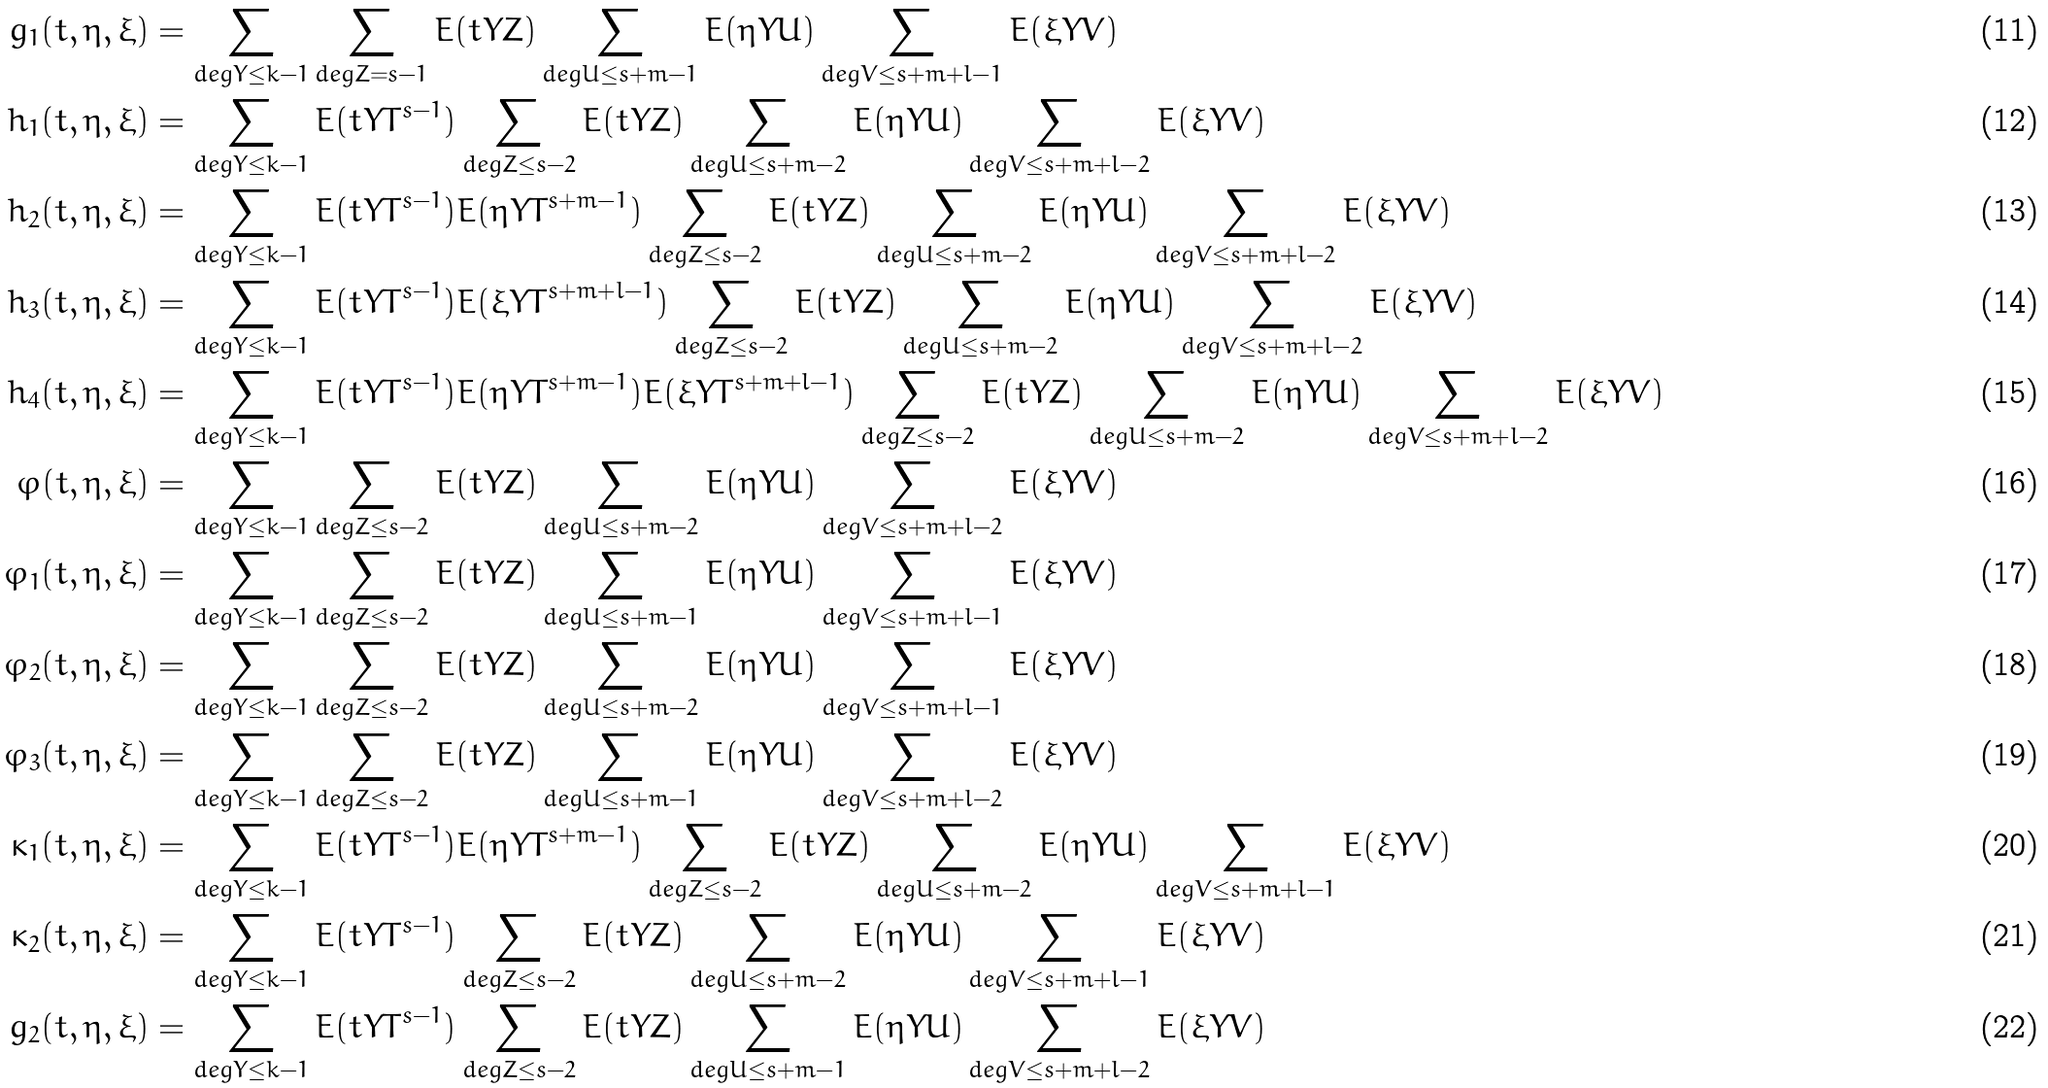<formula> <loc_0><loc_0><loc_500><loc_500>g _ { 1 } ( t , \eta , \xi ) & = \sum _ { d e g Y \leq k - 1 } \sum _ { d e g Z = s - 1 } E ( t Y Z ) \sum _ { d e g U \leq s + m - 1 } E ( \eta Y U ) \sum _ { d e g V \leq s + m + l - 1 } E ( \xi Y V ) \\ h _ { 1 } ( t , \eta , \xi ) & = \sum _ { d e g Y \leq k - 1 } E ( t Y T ^ { s - 1 } ) \sum _ { d e g Z \leq s - 2 } E ( t Y Z ) \sum _ { d e g U \leq s + m - 2 } E ( \eta Y U ) \sum _ { d e g V \leq s + m + l - 2 } E ( \xi Y V ) \\ h _ { 2 } ( t , \eta , \xi ) & = \sum _ { d e g Y \leq k - 1 } E ( t Y T ^ { s - 1 } ) E ( \eta Y T ^ { s + m - 1 } ) \sum _ { d e g Z \leq s - 2 } E ( t Y Z ) \sum _ { d e g U \leq s + m - 2 } E ( \eta Y U ) \sum _ { d e g V \leq s + m + l - 2 } E ( \xi Y V ) \\ h _ { 3 } ( t , \eta , \xi ) & = \sum _ { d e g Y \leq k - 1 } E ( t Y T ^ { s - 1 } ) E ( \xi Y T ^ { s + m + l - 1 } ) \sum _ { d e g Z \leq s - 2 } E ( t Y Z ) \sum _ { d e g U \leq s + m - 2 } E ( \eta Y U ) \sum _ { d e g V \leq s + m + l - 2 } E ( \xi Y V ) \\ h _ { 4 } ( t , \eta , \xi ) & = \sum _ { d e g Y \leq k - 1 } E ( t Y T ^ { s - 1 } ) E ( \eta Y T ^ { s + m - 1 } ) E ( \xi Y T ^ { s + m + l - 1 } ) \sum _ { d e g Z \leq s - 2 } E ( t Y Z ) \sum _ { d e g U \leq s + m - 2 } E ( \eta Y U ) \sum _ { d e g V \leq s + m + l - 2 } E ( \xi Y V ) \\ \varphi ( t , \eta , \xi ) & = \sum _ { d e g Y \leq k - 1 } \sum _ { d e g Z \leq s - 2 } E ( t Y Z ) \sum _ { d e g U \leq s + m - 2 } E ( \eta Y U ) \sum _ { d e g V \leq s + m + l - 2 } E ( \xi Y V ) \\ \varphi _ { 1 } ( t , \eta , \xi ) & = \sum _ { d e g Y \leq k - 1 } \sum _ { d e g Z \leq s - 2 } E ( t Y Z ) \sum _ { d e g U \leq s + m - 1 } E ( \eta Y U ) \sum _ { d e g V \leq s + m + l - 1 } E ( \xi Y V ) \\ \varphi _ { 2 } ( t , \eta , \xi ) & = \sum _ { d e g Y \leq k - 1 } \sum _ { d e g Z \leq s - 2 } E ( t Y Z ) \sum _ { d e g U \leq s + m - 2 } E ( \eta Y U ) \sum _ { d e g V \leq s + m + l - 1 } E ( \xi Y V ) \\ \varphi _ { 3 } ( t , \eta , \xi ) & = \sum _ { d e g Y \leq k - 1 } \sum _ { d e g Z \leq s - 2 } E ( t Y Z ) \sum _ { d e g U \leq s + m - 1 } E ( \eta Y U ) \sum _ { d e g V \leq s + m + l - 2 } E ( \xi Y V ) \\ \kappa _ { 1 } ( t , \eta , \xi ) & = \sum _ { d e g Y \leq k - 1 } E ( t Y T ^ { s - 1 } ) E ( \eta Y T ^ { s + m - 1 } ) \sum _ { d e g Z \leq s - 2 } E ( t Y Z ) \sum _ { d e g U \leq s + m - 2 } E ( \eta Y U ) \sum _ { d e g V \leq s + m + l - 1 } E ( \xi Y V ) \\ \kappa _ { 2 } ( t , \eta , \xi ) & = \sum _ { d e g Y \leq k - 1 } E ( t Y T ^ { s - 1 } ) \sum _ { d e g Z \leq s - 2 } E ( t Y Z ) \sum _ { d e g U \leq s + m - 2 } E ( \eta Y U ) \sum _ { d e g V \leq s + m + l - 1 } E ( \xi Y V ) \\ g _ { 2 } ( t , \eta , \xi ) & = \sum _ { d e g Y \leq k - 1 } E ( t Y T ^ { s - 1 } ) \sum _ { d e g Z \leq s - 2 } E ( t Y Z ) \sum _ { d e g U \leq s + m - 1 } E ( \eta Y U ) \sum _ { d e g V \leq s + m + l - 2 } E ( \xi Y V )</formula> 